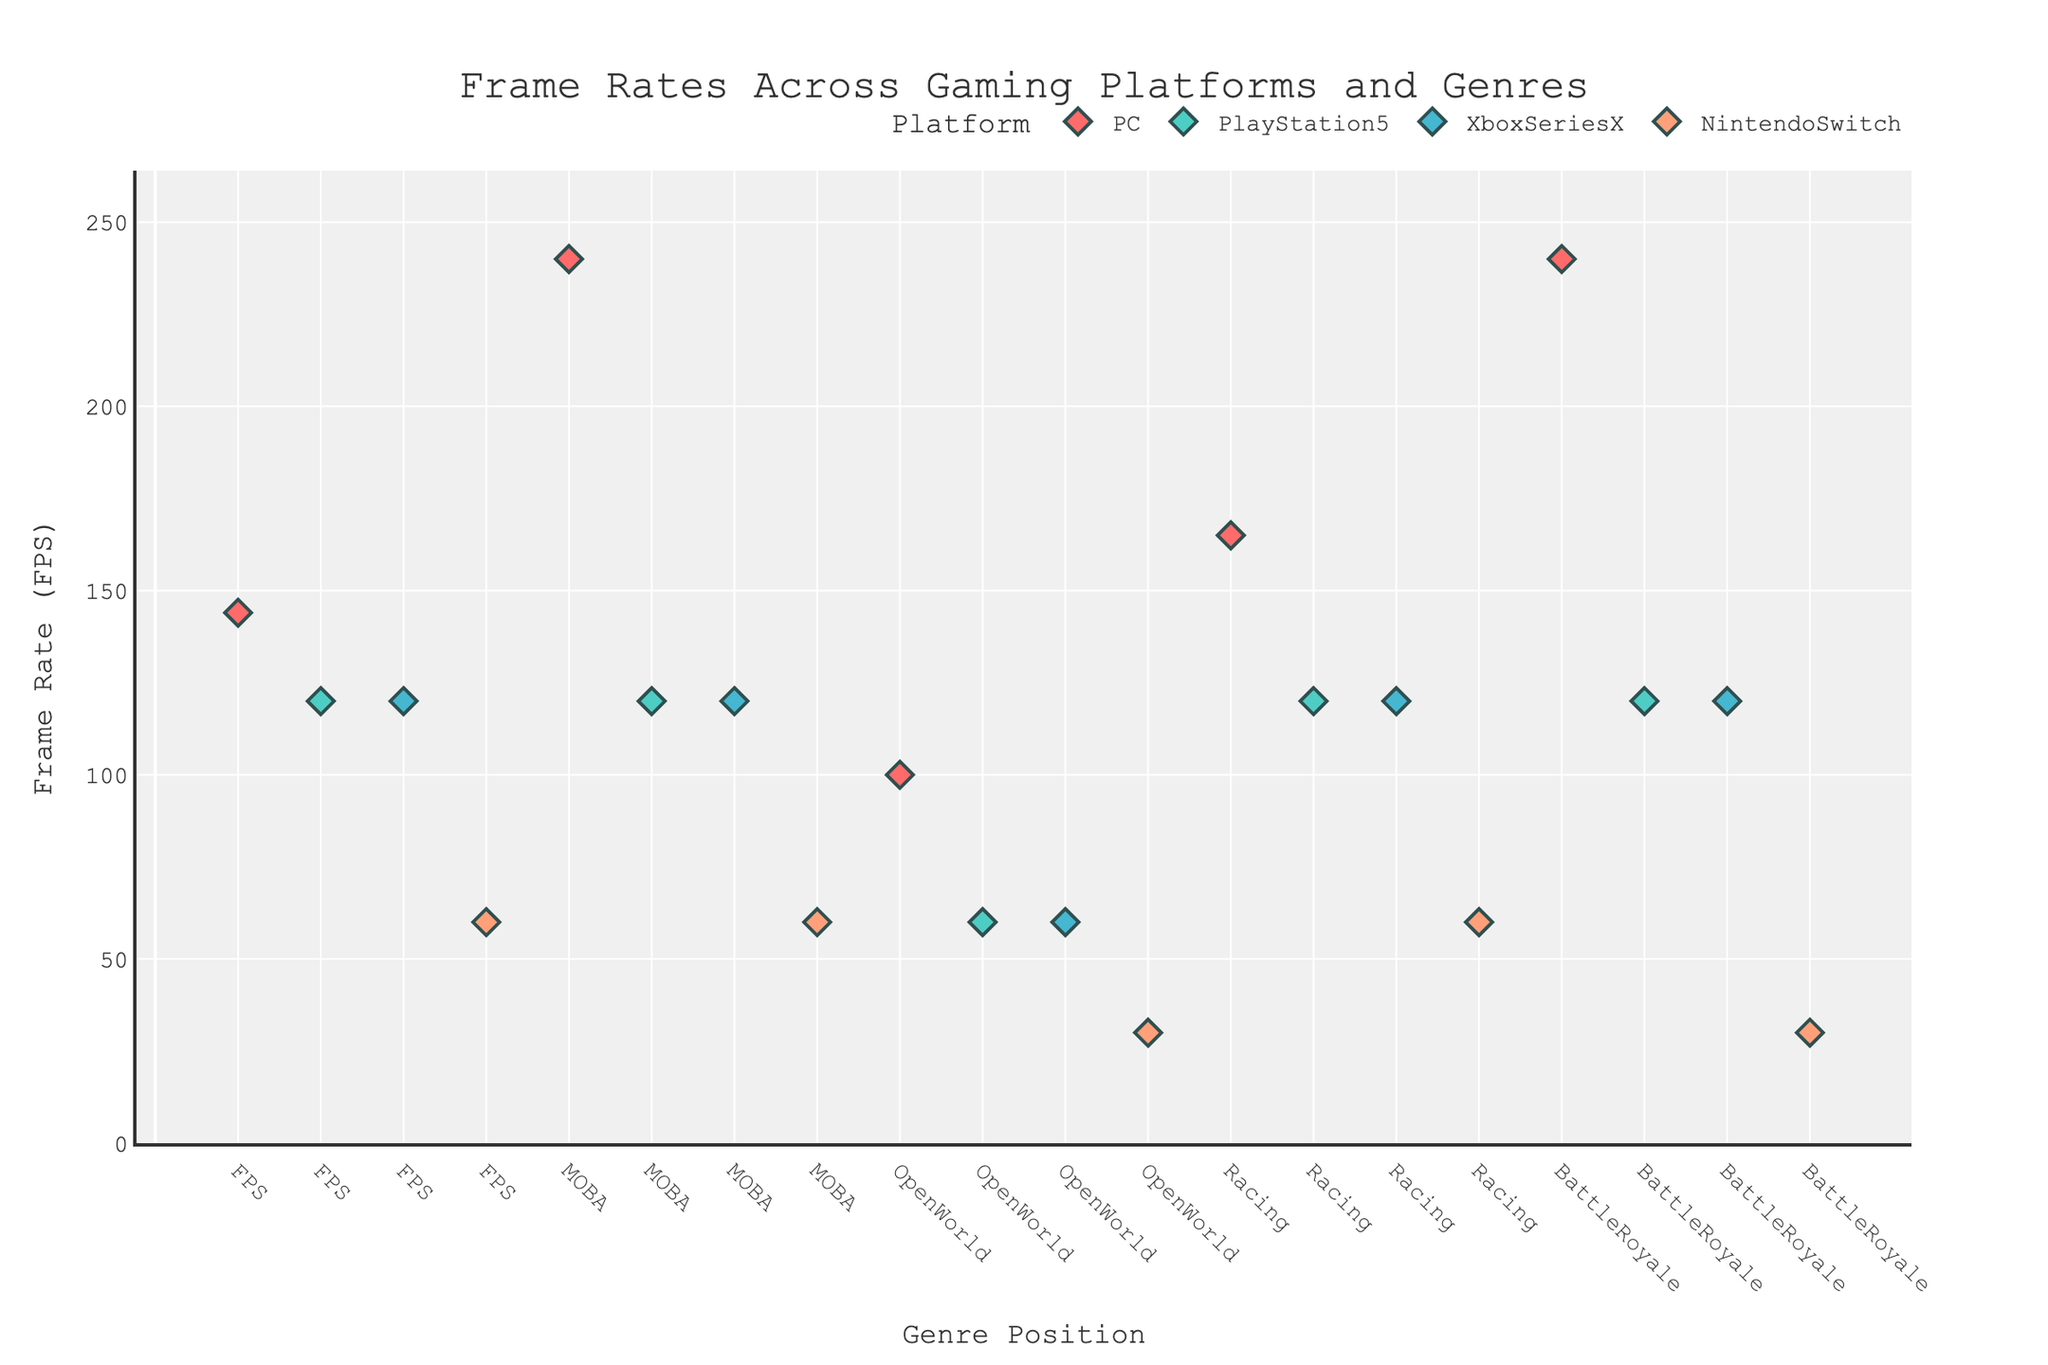What's the highest frame rate observed and on which platform and genre? The highest frame rate observed in the figure is 240 FPS. This happens twice: once for the PC platform in the MOBA genre and once for the PC platform in the Battle Royale genre.
Answer: 240 FPS on PC for MOBA and Battle Royale Which platform consistently has the lowest frame rate across all genres? By looking at the frame rates across all genres, it’s clear that the Nintendo Switch consistently has the lowest frame rates in each genre when compared to other platforms.
Answer: Nintendo Switch In the FPS genre, which platform has the highest frame rate? In the FPS genre, the frame rates are: PC (144 FPS), PlayStation5 (120 FPS), XboxSeriesX (120 FPS), and NintendoSwitch (60 FPS). The highest frame rate is on the PC with 144 FPS.
Answer: PC What is the frame rate difference between the PC and Nintendo Switch in the Open World genre? In the Open World genre, the frame rates are 100 FPS for PC and 30 FPS for Nintendo Switch. The difference can be calculated as 100 FPS - 30 FPS = 70 FPS.
Answer: 70 FPS How does the frame rate of PlayStation5 compare to XboxSeriesX in the Battle Royale genre? For the Battle Royale genre, both PlayStation5 and XboxSeriesX have the same frame rate of 120 FPS.
Answer: Equal at 120 FPS Which genre shows the maximum frame rate across all platforms and what is the value? The Battle Royale and MOBA genres show the maximum frame rate of 240 FPS on the PC platform. This is the highest frame rate observed across all platforms and genres.
Answer: Battle Royale and MOBA at 240 FPS On which genres does the Nintendo Switch show a frame rate of 60 FPS? The Nintendo Switch shows a frame rate of 60 FPS in the FPS, MOBA, and Racing genres.
Answer: FPS, MOBA, and Racing What's the total sum of frame rates for the PC platform across all genres? Add the frame rates from all genres for the PC platform: 144 (FPS) + 240 (MOBA) + 100 (Open World) + 165 (Racing) + 240 (Battle Royale) = 889 FPS.
Answer: 889 FPS In the Racing genre, which platform has the highest frame rate and what is it? The frame rates in the Racing genre are: PC (165 FPS), PlayStation5 (120 FPS), XboxSeriesX (120 FPS), and NintendoSwitch (60 FPS). The highest frame rate is on the PC with 165 FPS.
Answer: PC with 165 FPS 